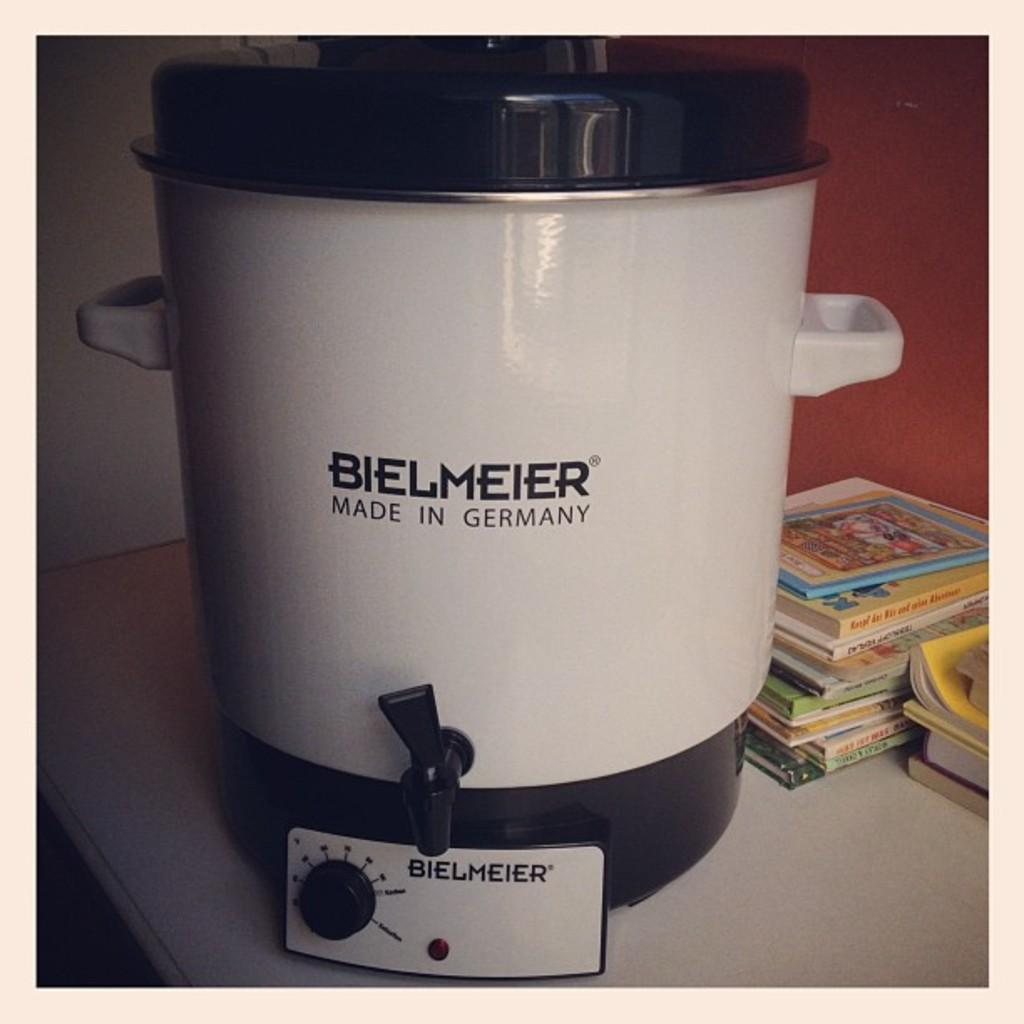Where is bielmeier made?
Ensure brevity in your answer.  Germany. 